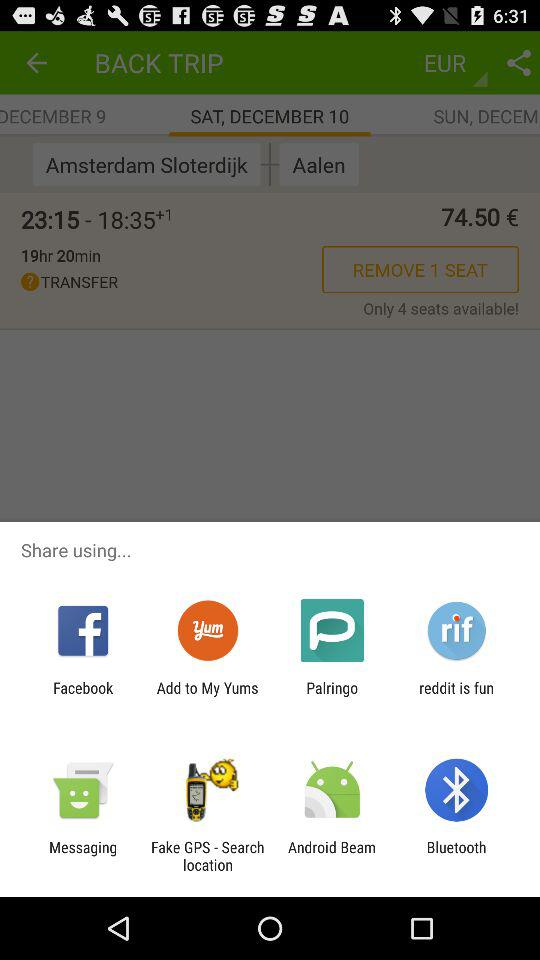What are the different options available for sharing? The different options available are "Facebook", "Add to My Yums", "Palringo", "reddit is fun", "Messaging", "Fake GPS - Search location", "Android Beam" and "Bluetooth". 